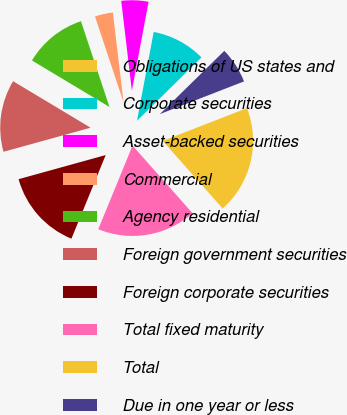Convert chart. <chart><loc_0><loc_0><loc_500><loc_500><pie_chart><fcel>Obligations of US states and<fcel>Corporate securities<fcel>Asset-backed securities<fcel>Commercial<fcel>Agency residential<fcel>Foreign government securities<fcel>Foreign corporate securities<fcel>Total fixed maturity<fcel>Total<fcel>Due in one year or less<nl><fcel>0.01%<fcel>9.68%<fcel>4.84%<fcel>3.23%<fcel>11.29%<fcel>12.9%<fcel>14.51%<fcel>17.74%<fcel>19.35%<fcel>6.45%<nl></chart> 